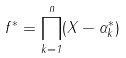<formula> <loc_0><loc_0><loc_500><loc_500>f ^ { * } = \prod _ { k = 1 } ^ { n } ( X - \alpha _ { k } ^ { * } )</formula> 